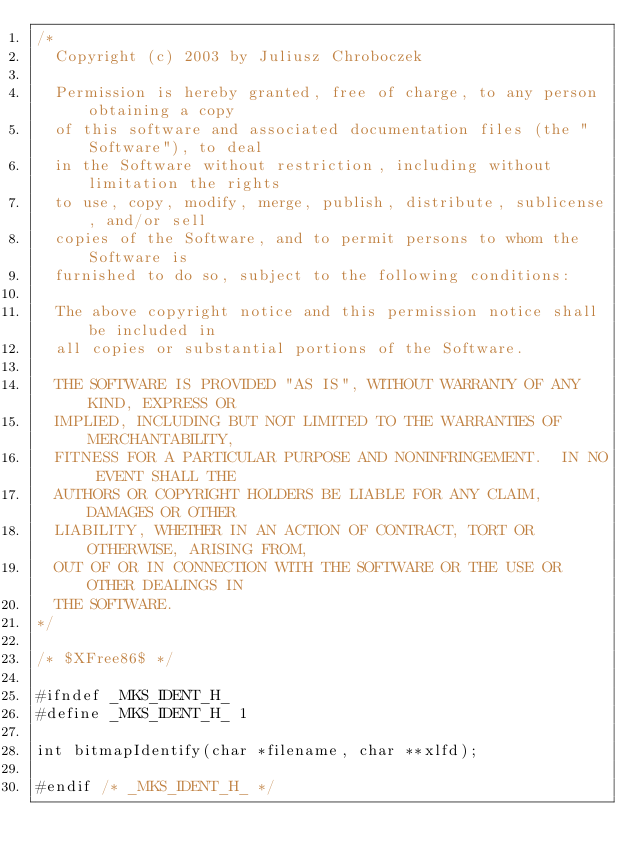Convert code to text. <code><loc_0><loc_0><loc_500><loc_500><_C_>/*
  Copyright (c) 2003 by Juliusz Chroboczek

  Permission is hereby granted, free of charge, to any person obtaining a copy
  of this software and associated documentation files (the "Software"), to deal
  in the Software without restriction, including without limitation the rights
  to use, copy, modify, merge, publish, distribute, sublicense, and/or sell
  copies of the Software, and to permit persons to whom the Software is
  furnished to do so, subject to the following conditions:

  The above copyright notice and this permission notice shall be included in
  all copies or substantial portions of the Software.

  THE SOFTWARE IS PROVIDED "AS IS", WITHOUT WARRANTY OF ANY KIND, EXPRESS OR
  IMPLIED, INCLUDING BUT NOT LIMITED TO THE WARRANTIES OF MERCHANTABILITY,
  FITNESS FOR A PARTICULAR PURPOSE AND NONINFRINGEMENT.  IN NO EVENT SHALL THE
  AUTHORS OR COPYRIGHT HOLDERS BE LIABLE FOR ANY CLAIM, DAMAGES OR OTHER
  LIABILITY, WHETHER IN AN ACTION OF CONTRACT, TORT OR OTHERWISE, ARISING FROM,
  OUT OF OR IN CONNECTION WITH THE SOFTWARE OR THE USE OR OTHER DEALINGS IN
  THE SOFTWARE.
*/

/* $XFree86$ */

#ifndef _MKS_IDENT_H_
#define _MKS_IDENT_H_ 1

int bitmapIdentify(char *filename, char **xlfd);

#endif /* _MKS_IDENT_H_ */
</code> 